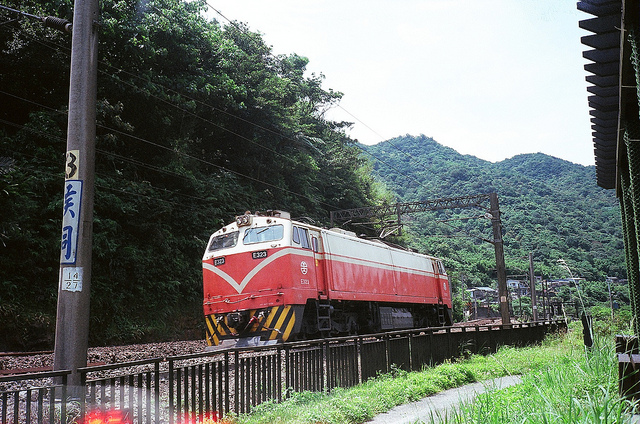Identify the text displayed in this image. 1323 3 27 14 